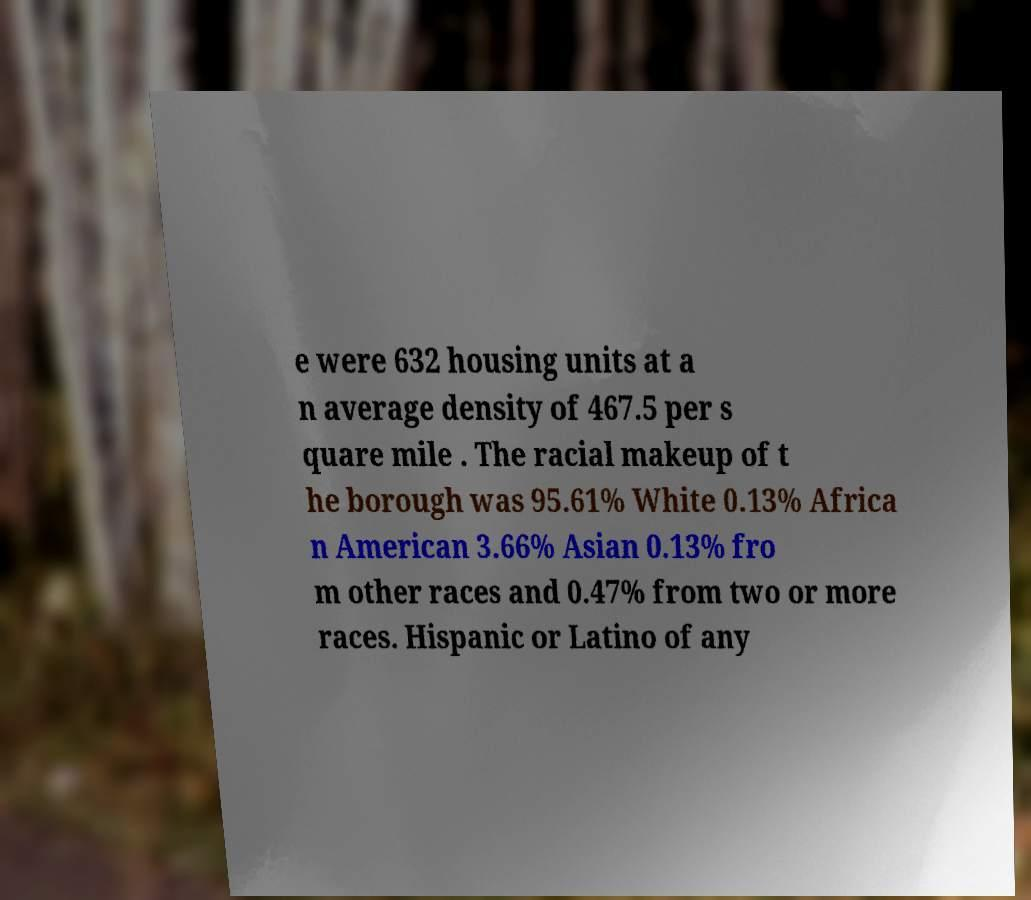For documentation purposes, I need the text within this image transcribed. Could you provide that? e were 632 housing units at a n average density of 467.5 per s quare mile . The racial makeup of t he borough was 95.61% White 0.13% Africa n American 3.66% Asian 0.13% fro m other races and 0.47% from two or more races. Hispanic or Latino of any 